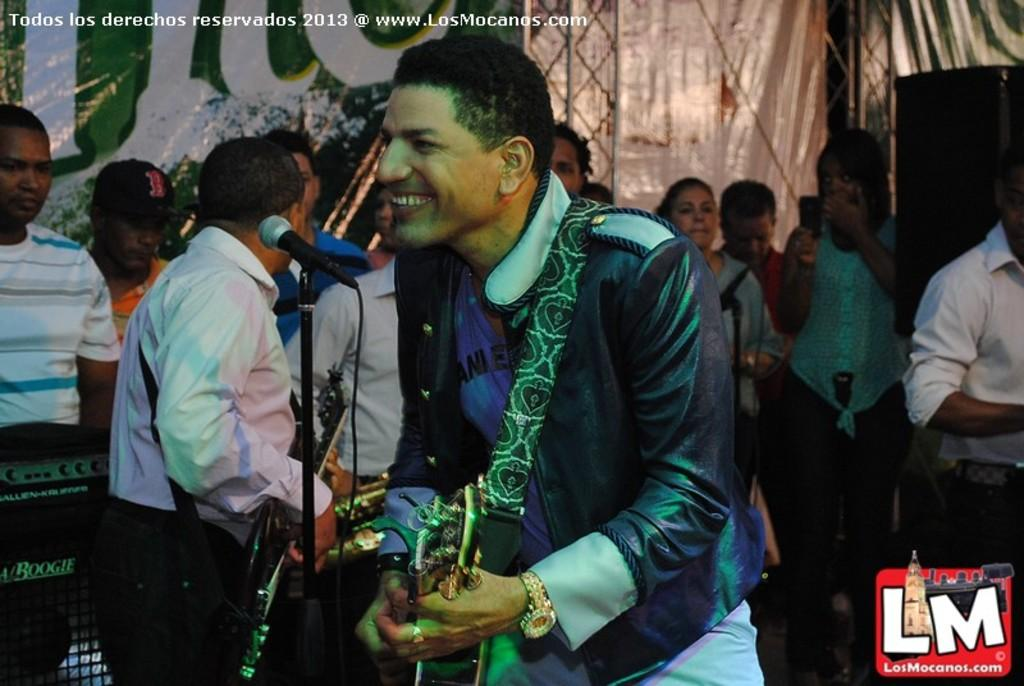What is the person near in the image? The person is near a microphone in the image. Can you describe the background of the image? There are people in the background of the image. What is written or displayed on a surface in the image? There is text written on a wall in the image. Where is the cactus located in the image? There is no cactus present in the image. What type of park can be seen in the background of the image? There is no park visible in the image; it features a person near a microphone and people in the background. 